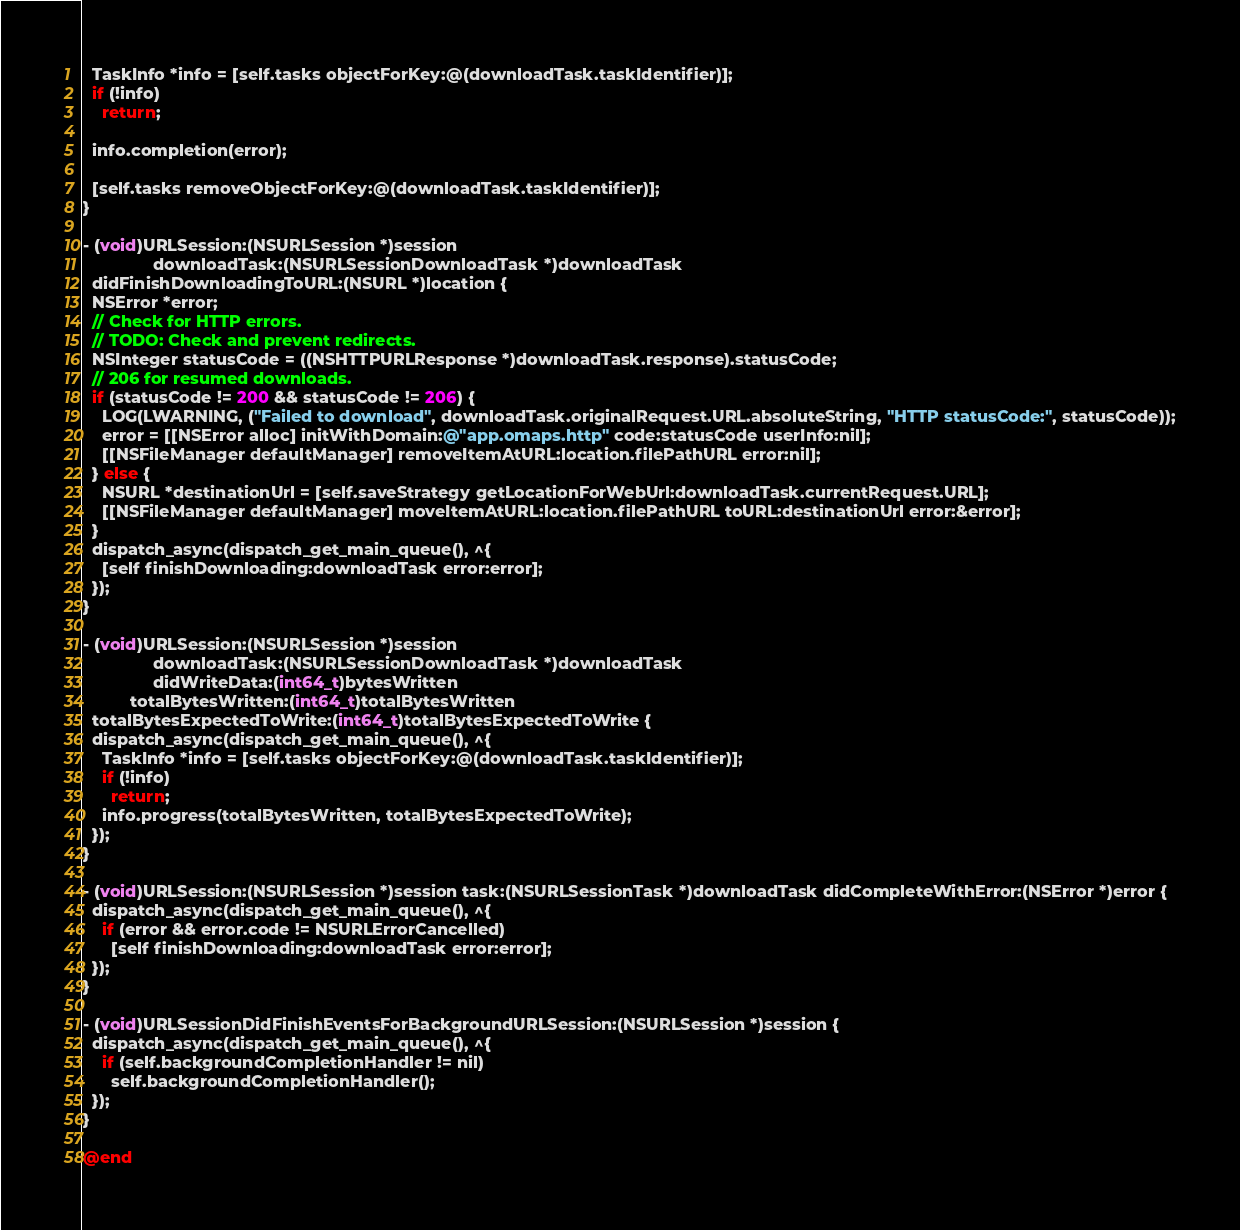Convert code to text. <code><loc_0><loc_0><loc_500><loc_500><_ObjectiveC_>  TaskInfo *info = [self.tasks objectForKey:@(downloadTask.taskIdentifier)];
  if (!info)
    return;

  info.completion(error);

  [self.tasks removeObjectForKey:@(downloadTask.taskIdentifier)];
}

- (void)URLSession:(NSURLSession *)session
               downloadTask:(NSURLSessionDownloadTask *)downloadTask
  didFinishDownloadingToURL:(NSURL *)location {
  NSError *error;
  // Check for HTTP errors.
  // TODO: Check and prevent redirects.
  NSInteger statusCode = ((NSHTTPURLResponse *)downloadTask.response).statusCode;
  // 206 for resumed downloads.
  if (statusCode != 200 && statusCode != 206) {
    LOG(LWARNING, ("Failed to download", downloadTask.originalRequest.URL.absoluteString, "HTTP statusCode:", statusCode));
    error = [[NSError alloc] initWithDomain:@"app.omaps.http" code:statusCode userInfo:nil];
    [[NSFileManager defaultManager] removeItemAtURL:location.filePathURL error:nil];
  } else {
    NSURL *destinationUrl = [self.saveStrategy getLocationForWebUrl:downloadTask.currentRequest.URL];
    [[NSFileManager defaultManager] moveItemAtURL:location.filePathURL toURL:destinationUrl error:&error];
  }
  dispatch_async(dispatch_get_main_queue(), ^{
    [self finishDownloading:downloadTask error:error];
  });
}

- (void)URLSession:(NSURLSession *)session
               downloadTask:(NSURLSessionDownloadTask *)downloadTask
               didWriteData:(int64_t)bytesWritten
          totalBytesWritten:(int64_t)totalBytesWritten
  totalBytesExpectedToWrite:(int64_t)totalBytesExpectedToWrite {
  dispatch_async(dispatch_get_main_queue(), ^{
    TaskInfo *info = [self.tasks objectForKey:@(downloadTask.taskIdentifier)];
    if (!info)
      return;
    info.progress(totalBytesWritten, totalBytesExpectedToWrite);
  });
}

- (void)URLSession:(NSURLSession *)session task:(NSURLSessionTask *)downloadTask didCompleteWithError:(NSError *)error {
  dispatch_async(dispatch_get_main_queue(), ^{
    if (error && error.code != NSURLErrorCancelled)
      [self finishDownloading:downloadTask error:error];
  });
}

- (void)URLSessionDidFinishEventsForBackgroundURLSession:(NSURLSession *)session {
  dispatch_async(dispatch_get_main_queue(), ^{
    if (self.backgroundCompletionHandler != nil)
      self.backgroundCompletionHandler();
  });
}

@end
</code> 